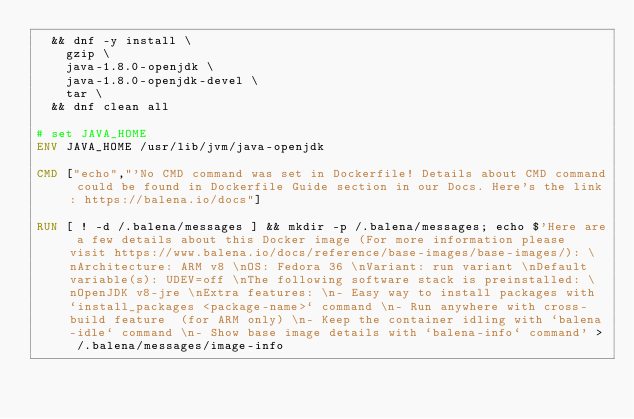Convert code to text. <code><loc_0><loc_0><loc_500><loc_500><_Dockerfile_>	&& dnf -y install \
		gzip \
		java-1.8.0-openjdk \
		java-1.8.0-openjdk-devel \
		tar \
	&& dnf clean all

# set JAVA_HOME
ENV JAVA_HOME /usr/lib/jvm/java-openjdk

CMD ["echo","'No CMD command was set in Dockerfile! Details about CMD command could be found in Dockerfile Guide section in our Docs. Here's the link: https://balena.io/docs"]

RUN [ ! -d /.balena/messages ] && mkdir -p /.balena/messages; echo $'Here are a few details about this Docker image (For more information please visit https://www.balena.io/docs/reference/base-images/base-images/): \nArchitecture: ARM v8 \nOS: Fedora 36 \nVariant: run variant \nDefault variable(s): UDEV=off \nThe following software stack is preinstalled: \nOpenJDK v8-jre \nExtra features: \n- Easy way to install packages with `install_packages <package-name>` command \n- Run anywhere with cross-build feature  (for ARM only) \n- Keep the container idling with `balena-idle` command \n- Show base image details with `balena-info` command' > /.balena/messages/image-info</code> 